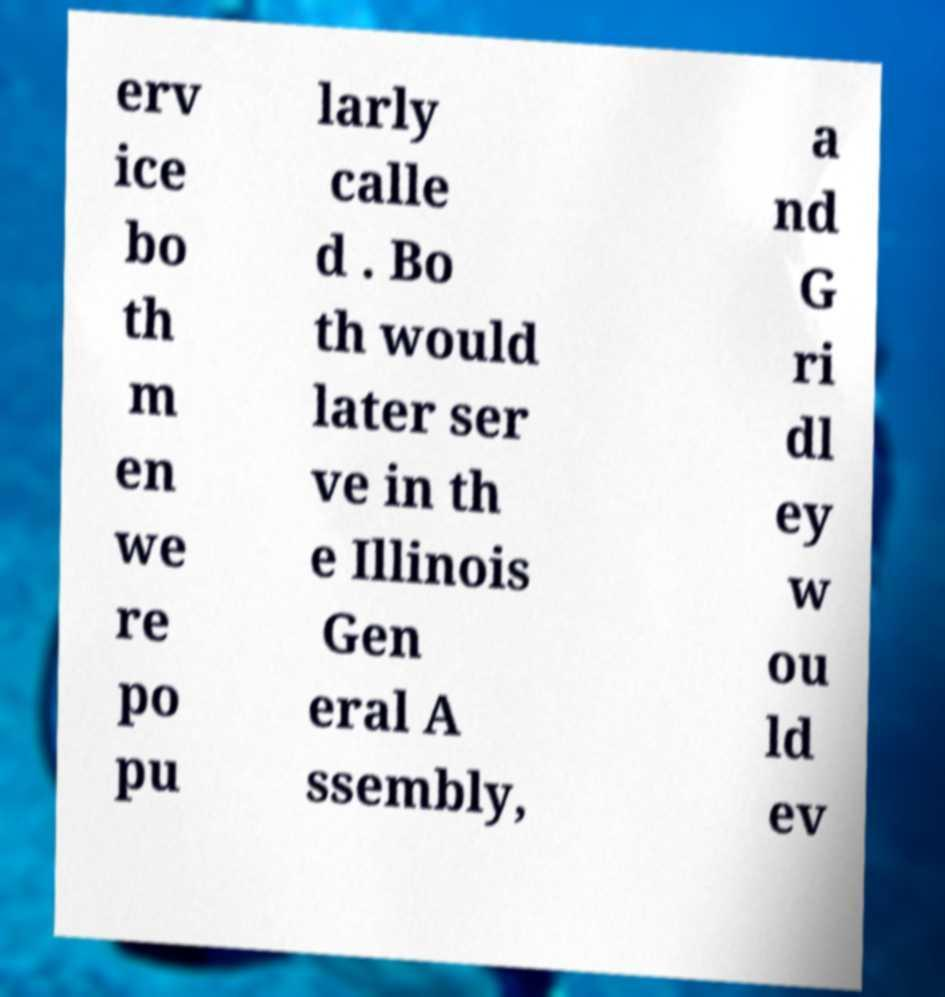Please read and relay the text visible in this image. What does it say? erv ice bo th m en we re po pu larly calle d . Bo th would later ser ve in th e Illinois Gen eral A ssembly, a nd G ri dl ey w ou ld ev 